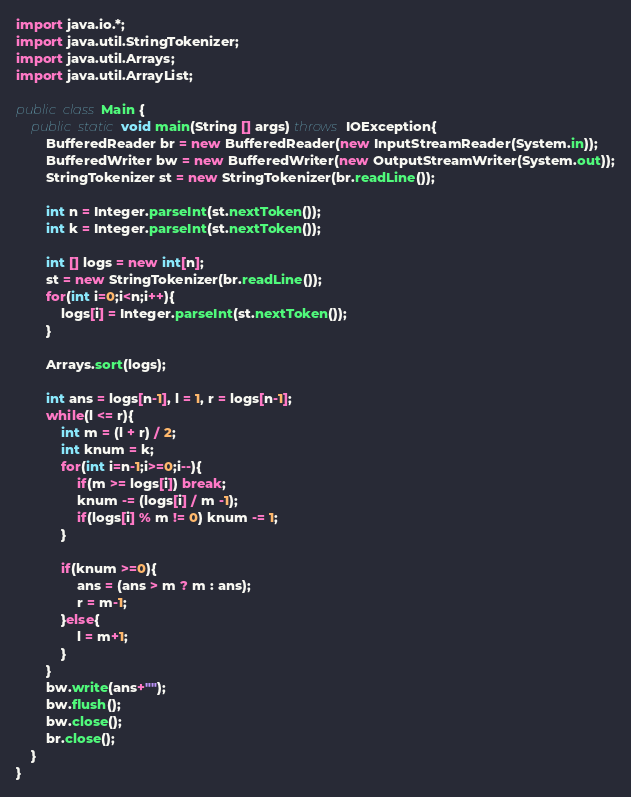<code> <loc_0><loc_0><loc_500><loc_500><_Java_>import java.io.*;
import java.util.StringTokenizer;
import java.util.Arrays;
import java.util.ArrayList;

public class Main {
    public static void main(String [] args) throws IOException{
        BufferedReader br = new BufferedReader(new InputStreamReader(System.in));
        BufferedWriter bw = new BufferedWriter(new OutputStreamWriter(System.out));
        StringTokenizer st = new StringTokenizer(br.readLine());

        int n = Integer.parseInt(st.nextToken());
        int k = Integer.parseInt(st.nextToken());

        int [] logs = new int[n];
        st = new StringTokenizer(br.readLine());
        for(int i=0;i<n;i++){
            logs[i] = Integer.parseInt(st.nextToken());
        }

        Arrays.sort(logs);

        int ans = logs[n-1], l = 1, r = logs[n-1];
        while(l <= r){
            int m = (l + r) / 2;
            int knum = k;
            for(int i=n-1;i>=0;i--){
                if(m >= logs[i]) break;
                knum -= (logs[i] / m -1);
                if(logs[i] % m != 0) knum -= 1;
            }

            if(knum >=0){
                ans = (ans > m ? m : ans);
                r = m-1;
            }else{
                l = m+1;
            }
        }
        bw.write(ans+"");
        bw.flush();
        bw.close();
        br.close();
    }
}
</code> 